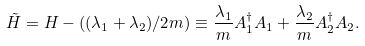<formula> <loc_0><loc_0><loc_500><loc_500>\tilde { H } = H - ( ( \lambda _ { 1 } + \lambda _ { 2 } ) / 2 m ) \equiv \frac { \lambda _ { 1 } } { m } A _ { 1 } ^ { \dagger } A _ { 1 } + \frac { \lambda _ { 2 } } { m } A _ { 2 } ^ { \dagger } A _ { 2 } .</formula> 